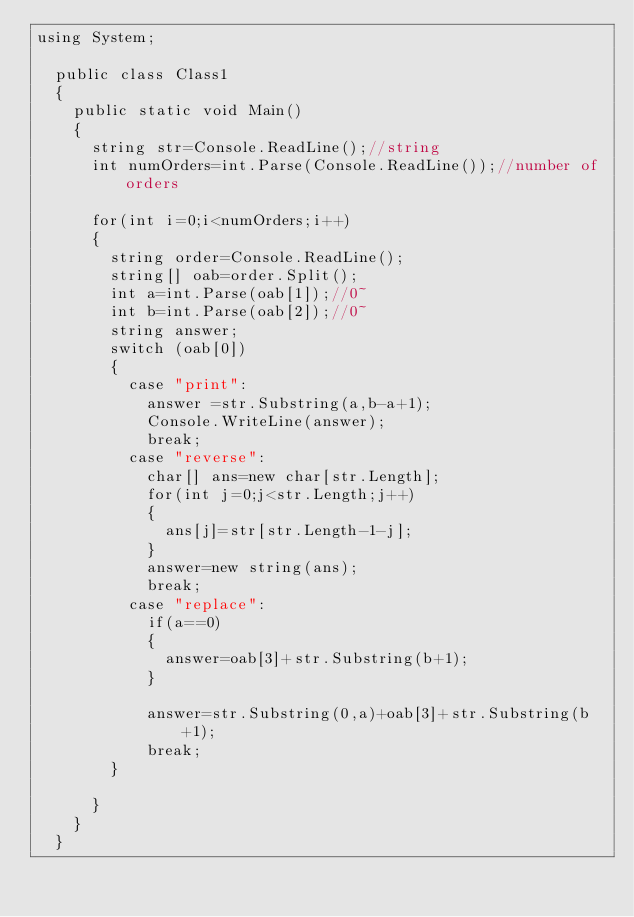<code> <loc_0><loc_0><loc_500><loc_500><_C#_>using System;

	public class Class1
	{
		public static void Main()
		{  
			string str=Console.ReadLine();//string
			int numOrders=int.Parse(Console.ReadLine());//number of orders
			
			for(int i=0;i<numOrders;i++)
			{
				string order=Console.ReadLine();
				string[] oab=order.Split();
				int a=int.Parse(oab[1]);//0~
				int b=int.Parse(oab[2]);//0~
				string answer;
				switch (oab[0])
				{
					case "print":
						answer =str.Substring(a,b-a+1);
						Console.WriteLine(answer);
						break;
					case "reverse":
						char[] ans=new char[str.Length];
						for(int j=0;j<str.Length;j++)
						{							
							ans[j]=str[str.Length-1-j];
						}
						answer=new string(ans);
						break;
					case "replace":
						if(a==0)
						{
							answer=oab[3]+str.Substring(b+1);
						}
											
						answer=str.Substring(0,a)+oab[3]+str.Substring(b+1);
						break;
				}
					
			}
		}
	}</code> 